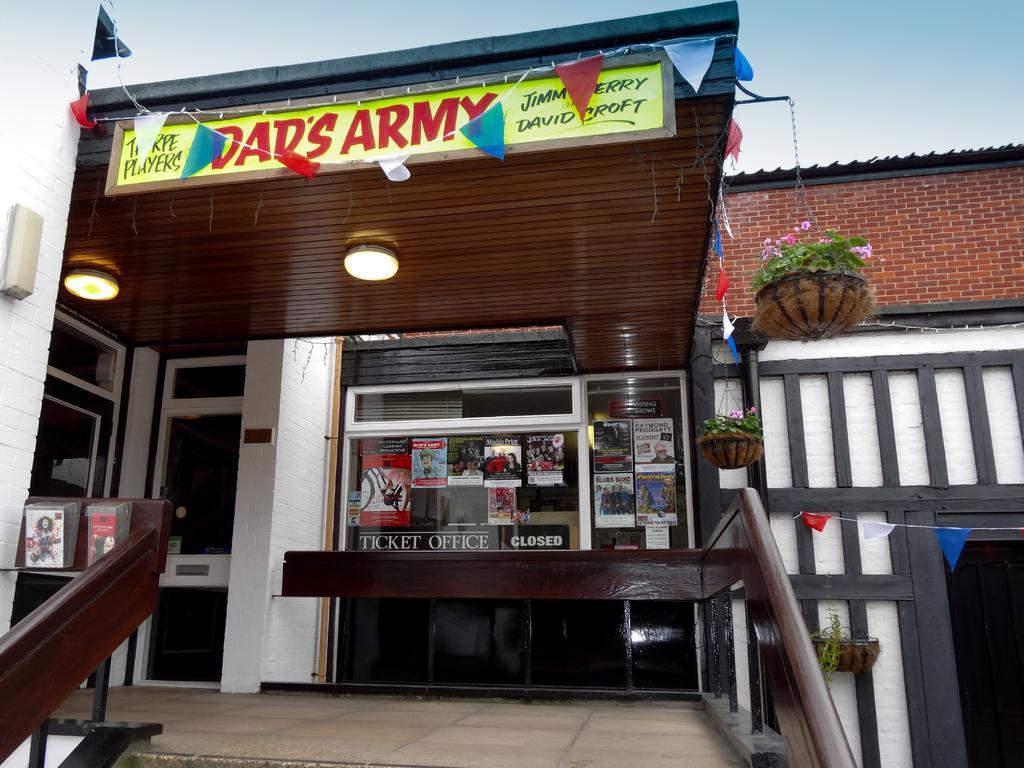How would you summarize this image in a sentence or two? At the bottom of the picture, we see a railing. Behind that, we see a glass door on which many posters are pasted. Beside that, we see a white pillar. On the left side, we see a table on which books are placed. On top of the building, we see a green color board with some text written on it. We even see flags in different colors. On the right side, we see a building in white color and flower pots. Behind that, we see a building which is made up of bricks. At the top of the picture, we see the sky. 